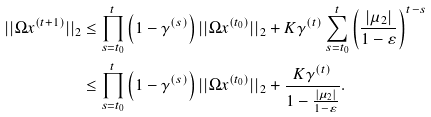Convert formula to latex. <formula><loc_0><loc_0><loc_500><loc_500>| | \Omega x ^ { ( t + 1 ) } | | _ { 2 } & \leq \prod _ { s = t _ { 0 } } ^ { t } \left ( 1 - \gamma ^ { ( s ) } \right ) | | \Omega x ^ { ( t _ { 0 } ) } | | _ { 2 } + K \gamma ^ { ( t ) } \sum _ { s = t _ { 0 } } ^ { t } \left ( \frac { | \mu _ { 2 } | } { 1 - \varepsilon } \right ) ^ { t - s } \\ & \leq \prod _ { s = t _ { 0 } } ^ { t } \left ( 1 - \gamma ^ { ( s ) } \right ) | | \Omega x ^ { ( t _ { 0 } ) } | | _ { 2 } + \frac { K \gamma ^ { ( t ) } } { 1 - \frac { | \mu _ { 2 } | } { 1 - \varepsilon } } .</formula> 